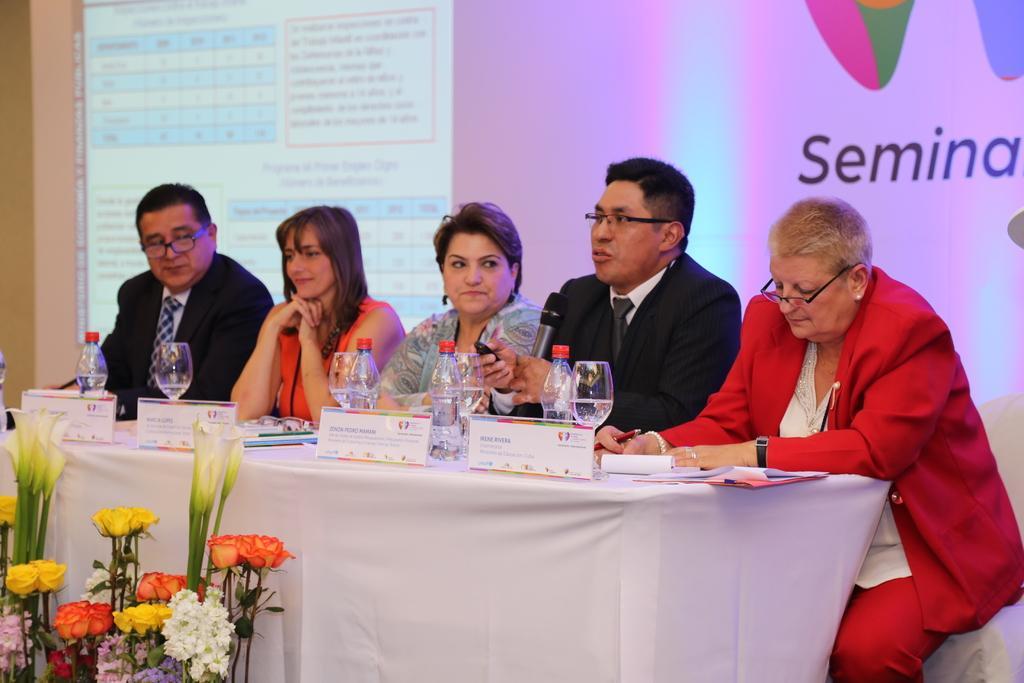In one or two sentences, can you explain what this image depicts? On the background we can see screen. here we can see few persons sitting on chairs in front of a table and on the table we can see water glass, water bottles, boards, book , paper and pen. These are flowers. 